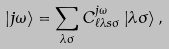<formula> <loc_0><loc_0><loc_500><loc_500>\left | j \omega \right \rangle = \sum _ { \lambda \sigma } C _ { \ell \lambda s \sigma } ^ { j \omega } \left | \lambda \sigma \right \rangle ,</formula> 